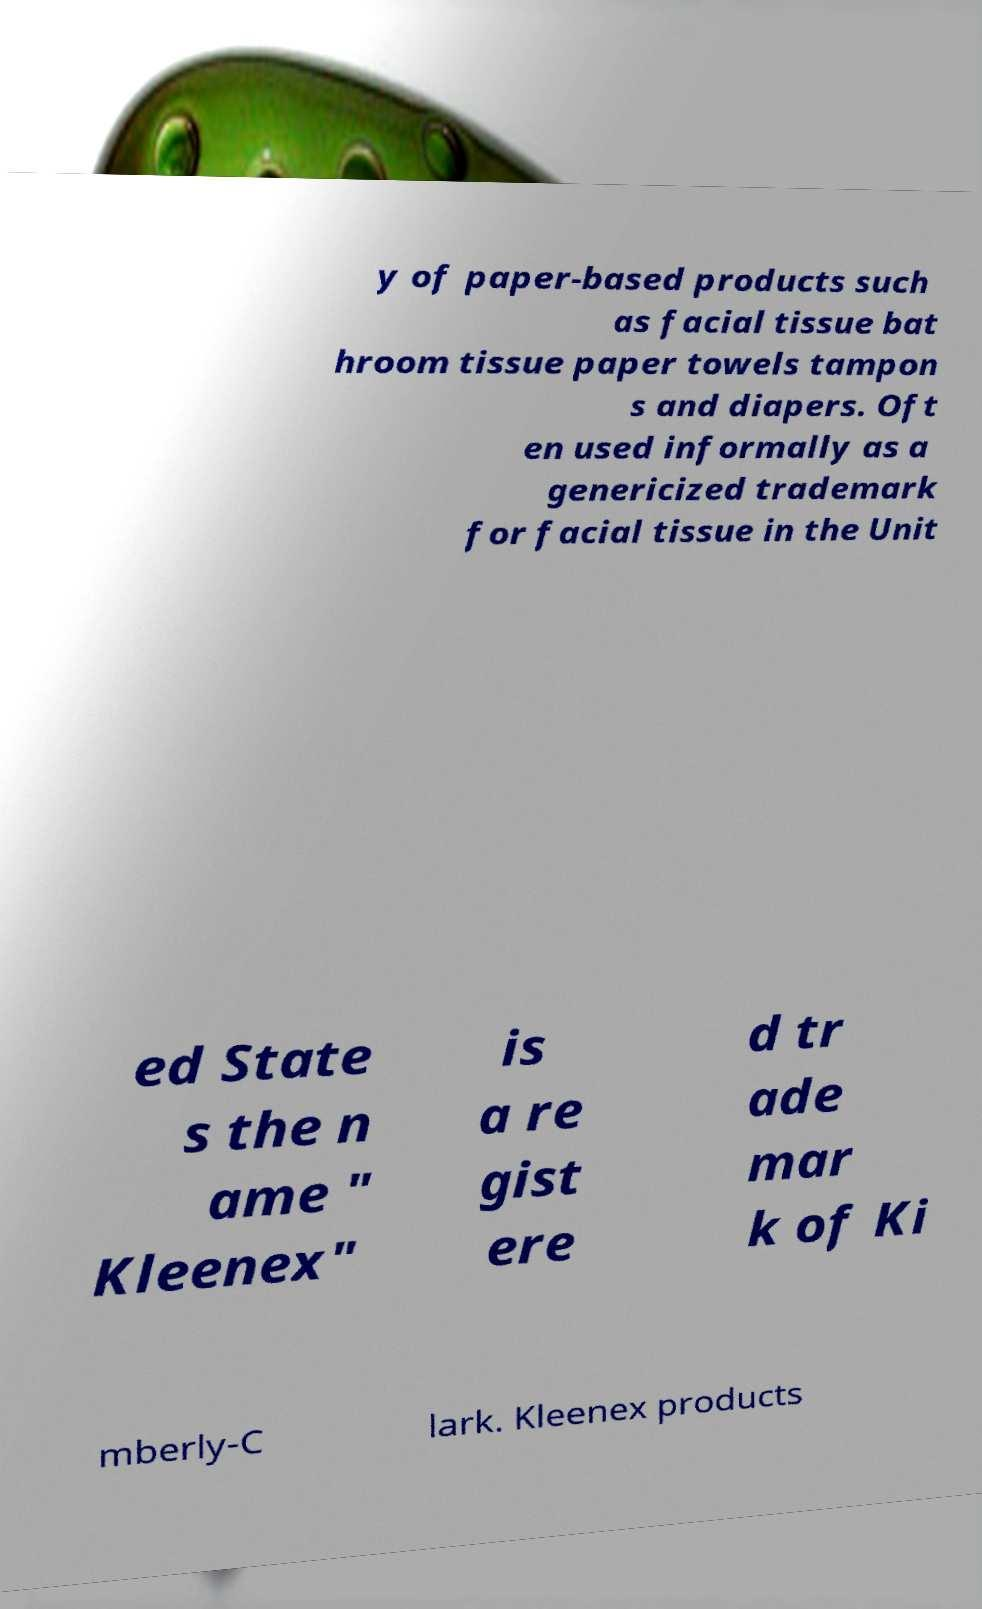There's text embedded in this image that I need extracted. Can you transcribe it verbatim? y of paper-based products such as facial tissue bat hroom tissue paper towels tampon s and diapers. Oft en used informally as a genericized trademark for facial tissue in the Unit ed State s the n ame " Kleenex" is a re gist ere d tr ade mar k of Ki mberly-C lark. Kleenex products 